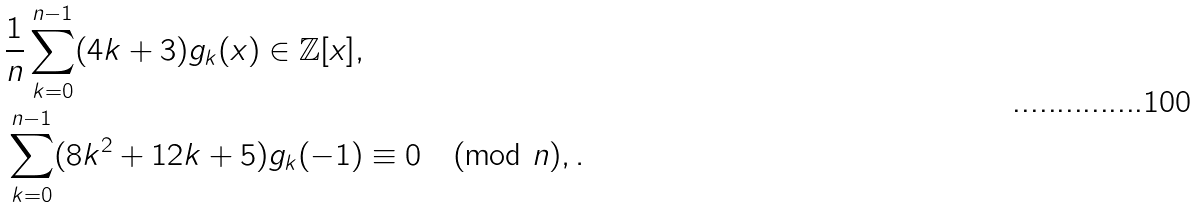Convert formula to latex. <formula><loc_0><loc_0><loc_500><loc_500>& \frac { 1 } { n } \sum _ { k = 0 } ^ { n - 1 } ( 4 k + 3 ) g _ { k } ( x ) \in \mathbb { Z } [ x ] , \\ & \sum _ { k = 0 } ^ { n - 1 } ( 8 k ^ { 2 } + 1 2 k + 5 ) g _ { k } ( - 1 ) \equiv 0 \pmod { n } , .</formula> 